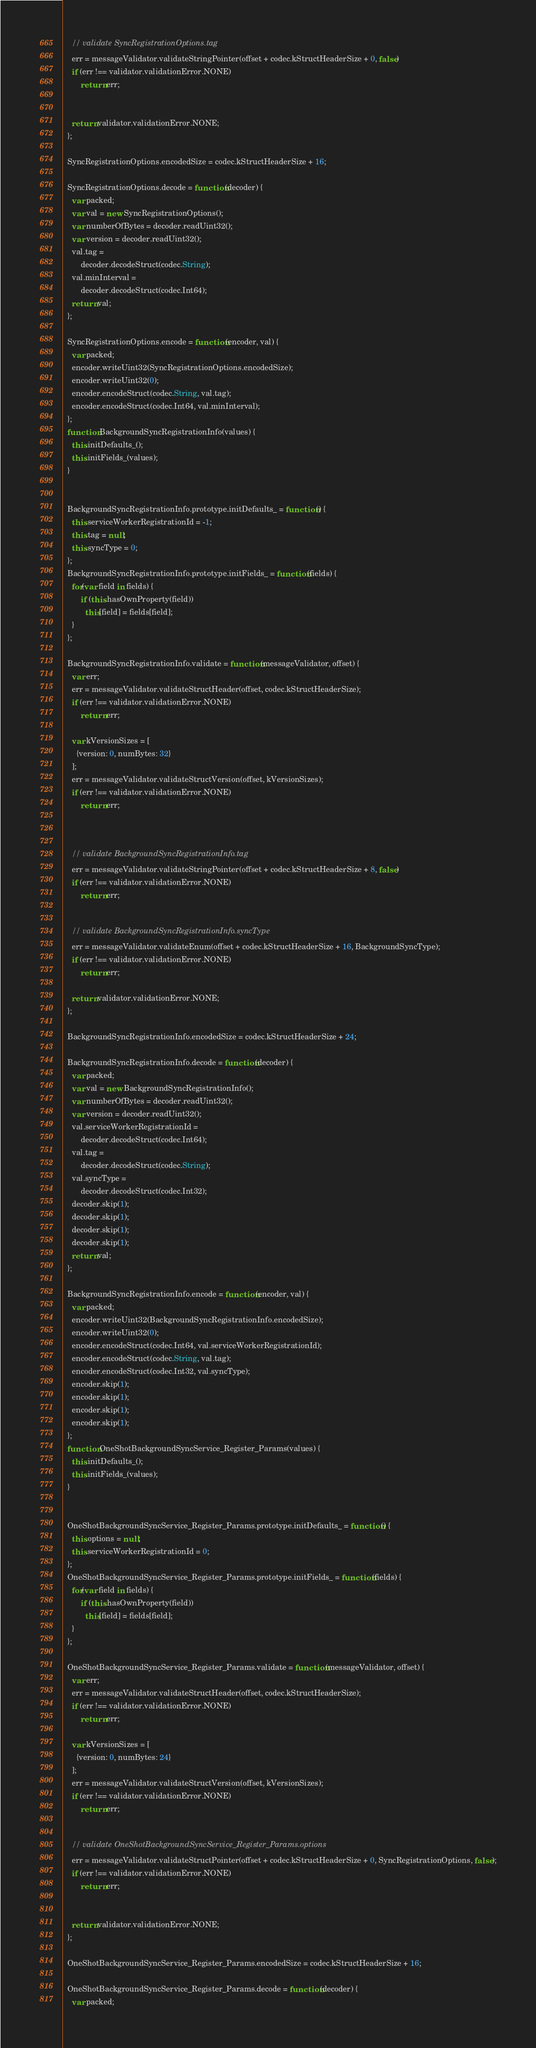Convert code to text. <code><loc_0><loc_0><loc_500><loc_500><_JavaScript_>    // validate SyncRegistrationOptions.tag
    err = messageValidator.validateStringPointer(offset + codec.kStructHeaderSize + 0, false)
    if (err !== validator.validationError.NONE)
        return err;


    return validator.validationError.NONE;
  };

  SyncRegistrationOptions.encodedSize = codec.kStructHeaderSize + 16;

  SyncRegistrationOptions.decode = function(decoder) {
    var packed;
    var val = new SyncRegistrationOptions();
    var numberOfBytes = decoder.readUint32();
    var version = decoder.readUint32();
    val.tag =
        decoder.decodeStruct(codec.String);
    val.minInterval =
        decoder.decodeStruct(codec.Int64);
    return val;
  };

  SyncRegistrationOptions.encode = function(encoder, val) {
    var packed;
    encoder.writeUint32(SyncRegistrationOptions.encodedSize);
    encoder.writeUint32(0);
    encoder.encodeStruct(codec.String, val.tag);
    encoder.encodeStruct(codec.Int64, val.minInterval);
  };
  function BackgroundSyncRegistrationInfo(values) {
    this.initDefaults_();
    this.initFields_(values);
  }


  BackgroundSyncRegistrationInfo.prototype.initDefaults_ = function() {
    this.serviceWorkerRegistrationId = -1;
    this.tag = null;
    this.syncType = 0;
  };
  BackgroundSyncRegistrationInfo.prototype.initFields_ = function(fields) {
    for(var field in fields) {
        if (this.hasOwnProperty(field))
          this[field] = fields[field];
    }
  };

  BackgroundSyncRegistrationInfo.validate = function(messageValidator, offset) {
    var err;
    err = messageValidator.validateStructHeader(offset, codec.kStructHeaderSize);
    if (err !== validator.validationError.NONE)
        return err;

    var kVersionSizes = [
      {version: 0, numBytes: 32}
    ];
    err = messageValidator.validateStructVersion(offset, kVersionSizes);
    if (err !== validator.validationError.NONE)
        return err;



    // validate BackgroundSyncRegistrationInfo.tag
    err = messageValidator.validateStringPointer(offset + codec.kStructHeaderSize + 8, false)
    if (err !== validator.validationError.NONE)
        return err;


    // validate BackgroundSyncRegistrationInfo.syncType
    err = messageValidator.validateEnum(offset + codec.kStructHeaderSize + 16, BackgroundSyncType);
    if (err !== validator.validationError.NONE)
        return err;

    return validator.validationError.NONE;
  };

  BackgroundSyncRegistrationInfo.encodedSize = codec.kStructHeaderSize + 24;

  BackgroundSyncRegistrationInfo.decode = function(decoder) {
    var packed;
    var val = new BackgroundSyncRegistrationInfo();
    var numberOfBytes = decoder.readUint32();
    var version = decoder.readUint32();
    val.serviceWorkerRegistrationId =
        decoder.decodeStruct(codec.Int64);
    val.tag =
        decoder.decodeStruct(codec.String);
    val.syncType =
        decoder.decodeStruct(codec.Int32);
    decoder.skip(1);
    decoder.skip(1);
    decoder.skip(1);
    decoder.skip(1);
    return val;
  };

  BackgroundSyncRegistrationInfo.encode = function(encoder, val) {
    var packed;
    encoder.writeUint32(BackgroundSyncRegistrationInfo.encodedSize);
    encoder.writeUint32(0);
    encoder.encodeStruct(codec.Int64, val.serviceWorkerRegistrationId);
    encoder.encodeStruct(codec.String, val.tag);
    encoder.encodeStruct(codec.Int32, val.syncType);
    encoder.skip(1);
    encoder.skip(1);
    encoder.skip(1);
    encoder.skip(1);
  };
  function OneShotBackgroundSyncService_Register_Params(values) {
    this.initDefaults_();
    this.initFields_(values);
  }


  OneShotBackgroundSyncService_Register_Params.prototype.initDefaults_ = function() {
    this.options = null;
    this.serviceWorkerRegistrationId = 0;
  };
  OneShotBackgroundSyncService_Register_Params.prototype.initFields_ = function(fields) {
    for(var field in fields) {
        if (this.hasOwnProperty(field))
          this[field] = fields[field];
    }
  };

  OneShotBackgroundSyncService_Register_Params.validate = function(messageValidator, offset) {
    var err;
    err = messageValidator.validateStructHeader(offset, codec.kStructHeaderSize);
    if (err !== validator.validationError.NONE)
        return err;

    var kVersionSizes = [
      {version: 0, numBytes: 24}
    ];
    err = messageValidator.validateStructVersion(offset, kVersionSizes);
    if (err !== validator.validationError.NONE)
        return err;


    // validate OneShotBackgroundSyncService_Register_Params.options
    err = messageValidator.validateStructPointer(offset + codec.kStructHeaderSize + 0, SyncRegistrationOptions, false);
    if (err !== validator.validationError.NONE)
        return err;


    return validator.validationError.NONE;
  };

  OneShotBackgroundSyncService_Register_Params.encodedSize = codec.kStructHeaderSize + 16;

  OneShotBackgroundSyncService_Register_Params.decode = function(decoder) {
    var packed;</code> 